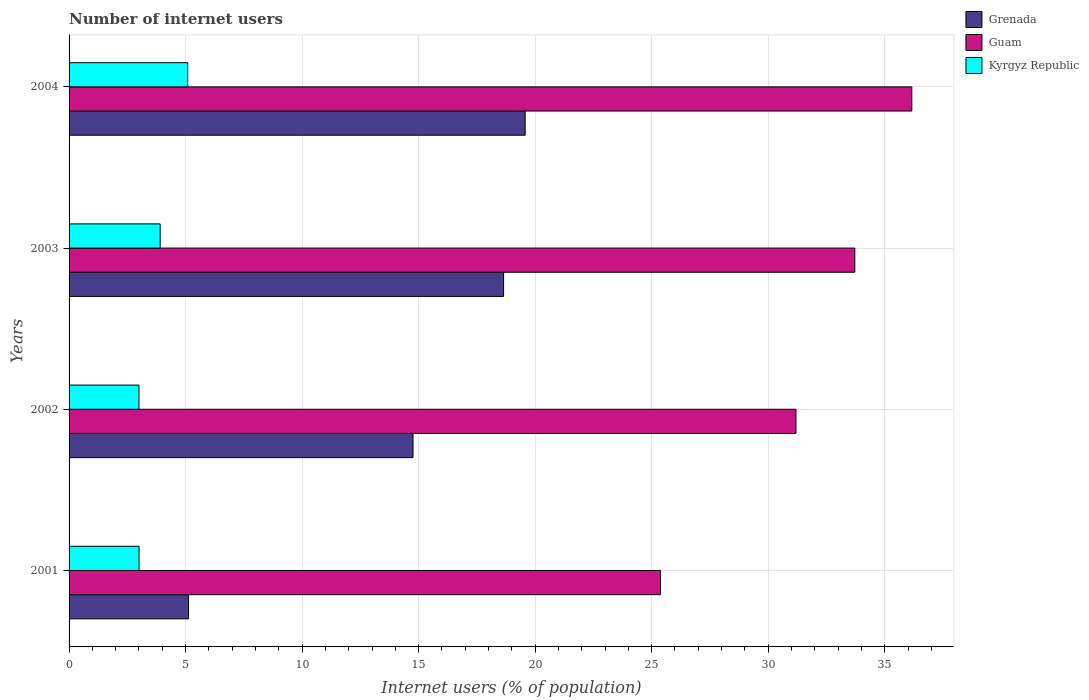How many different coloured bars are there?
Ensure brevity in your answer.  3. What is the number of internet users in Kyrgyz Republic in 2001?
Provide a succinct answer. 3. Across all years, what is the maximum number of internet users in Grenada?
Your response must be concise. 19.57. Across all years, what is the minimum number of internet users in Guam?
Your answer should be very brief. 25.38. In which year was the number of internet users in Kyrgyz Republic maximum?
Provide a succinct answer. 2004. In which year was the number of internet users in Kyrgyz Republic minimum?
Make the answer very short. 2002. What is the total number of internet users in Grenada in the graph?
Your answer should be compact. 58.1. What is the difference between the number of internet users in Grenada in 2002 and that in 2004?
Offer a very short reply. -4.81. What is the difference between the number of internet users in Guam in 2001 and the number of internet users in Grenada in 2003?
Give a very brief answer. 6.74. What is the average number of internet users in Guam per year?
Make the answer very short. 31.61. In the year 2004, what is the difference between the number of internet users in Grenada and number of internet users in Guam?
Offer a terse response. -16.59. What is the ratio of the number of internet users in Kyrgyz Republic in 2001 to that in 2004?
Make the answer very short. 0.59. Is the difference between the number of internet users in Grenada in 2001 and 2002 greater than the difference between the number of internet users in Guam in 2001 and 2002?
Offer a terse response. No. What is the difference between the highest and the second highest number of internet users in Grenada?
Your answer should be very brief. 0.93. What is the difference between the highest and the lowest number of internet users in Guam?
Provide a succinct answer. 10.78. In how many years, is the number of internet users in Grenada greater than the average number of internet users in Grenada taken over all years?
Your answer should be very brief. 3. Is the sum of the number of internet users in Kyrgyz Republic in 2003 and 2004 greater than the maximum number of internet users in Guam across all years?
Give a very brief answer. No. What does the 2nd bar from the top in 2002 represents?
Offer a terse response. Guam. What does the 3rd bar from the bottom in 2003 represents?
Offer a very short reply. Kyrgyz Republic. Is it the case that in every year, the sum of the number of internet users in Kyrgyz Republic and number of internet users in Guam is greater than the number of internet users in Grenada?
Provide a succinct answer. Yes. How many bars are there?
Make the answer very short. 12. Are all the bars in the graph horizontal?
Your answer should be compact. Yes. Are the values on the major ticks of X-axis written in scientific E-notation?
Offer a very short reply. No. Does the graph contain grids?
Ensure brevity in your answer.  Yes. Where does the legend appear in the graph?
Give a very brief answer. Top right. What is the title of the graph?
Provide a succinct answer. Number of internet users. Does "Central Europe" appear as one of the legend labels in the graph?
Give a very brief answer. No. What is the label or title of the X-axis?
Your answer should be very brief. Internet users (% of population). What is the Internet users (% of population) of Grenada in 2001?
Give a very brief answer. 5.13. What is the Internet users (% of population) in Guam in 2001?
Offer a very short reply. 25.38. What is the Internet users (% of population) of Kyrgyz Republic in 2001?
Give a very brief answer. 3. What is the Internet users (% of population) of Grenada in 2002?
Provide a succinct answer. 14.76. What is the Internet users (% of population) of Guam in 2002?
Give a very brief answer. 31.19. What is the Internet users (% of population) of Kyrgyz Republic in 2002?
Provide a short and direct response. 3. What is the Internet users (% of population) of Grenada in 2003?
Make the answer very short. 18.65. What is the Internet users (% of population) in Guam in 2003?
Offer a very short reply. 33.72. What is the Internet users (% of population) of Kyrgyz Republic in 2003?
Offer a terse response. 3.91. What is the Internet users (% of population) of Grenada in 2004?
Provide a short and direct response. 19.57. What is the Internet users (% of population) of Guam in 2004?
Offer a terse response. 36.16. What is the Internet users (% of population) of Kyrgyz Republic in 2004?
Make the answer very short. 5.09. Across all years, what is the maximum Internet users (% of population) in Grenada?
Provide a short and direct response. 19.57. Across all years, what is the maximum Internet users (% of population) in Guam?
Your answer should be compact. 36.16. Across all years, what is the maximum Internet users (% of population) in Kyrgyz Republic?
Your answer should be compact. 5.09. Across all years, what is the minimum Internet users (% of population) of Grenada?
Your answer should be very brief. 5.13. Across all years, what is the minimum Internet users (% of population) of Guam?
Your answer should be compact. 25.38. Across all years, what is the minimum Internet users (% of population) of Kyrgyz Republic?
Your answer should be very brief. 3. What is the total Internet users (% of population) in Grenada in the graph?
Keep it short and to the point. 58.1. What is the total Internet users (% of population) of Guam in the graph?
Offer a terse response. 126.45. What is the total Internet users (% of population) in Kyrgyz Republic in the graph?
Give a very brief answer. 15. What is the difference between the Internet users (% of population) in Grenada in 2001 and that in 2002?
Your answer should be very brief. -9.63. What is the difference between the Internet users (% of population) in Guam in 2001 and that in 2002?
Provide a succinct answer. -5.81. What is the difference between the Internet users (% of population) of Kyrgyz Republic in 2001 and that in 2002?
Give a very brief answer. 0. What is the difference between the Internet users (% of population) of Grenada in 2001 and that in 2003?
Your answer should be compact. -13.52. What is the difference between the Internet users (% of population) in Guam in 2001 and that in 2003?
Keep it short and to the point. -8.34. What is the difference between the Internet users (% of population) in Kyrgyz Republic in 2001 and that in 2003?
Provide a short and direct response. -0.91. What is the difference between the Internet users (% of population) in Grenada in 2001 and that in 2004?
Provide a succinct answer. -14.44. What is the difference between the Internet users (% of population) of Guam in 2001 and that in 2004?
Your answer should be very brief. -10.78. What is the difference between the Internet users (% of population) of Kyrgyz Republic in 2001 and that in 2004?
Your answer should be very brief. -2.09. What is the difference between the Internet users (% of population) in Grenada in 2002 and that in 2003?
Offer a very short reply. -3.89. What is the difference between the Internet users (% of population) in Guam in 2002 and that in 2003?
Your answer should be compact. -2.52. What is the difference between the Internet users (% of population) in Kyrgyz Republic in 2002 and that in 2003?
Your response must be concise. -0.91. What is the difference between the Internet users (% of population) of Grenada in 2002 and that in 2004?
Offer a very short reply. -4.81. What is the difference between the Internet users (% of population) in Guam in 2002 and that in 2004?
Provide a succinct answer. -4.97. What is the difference between the Internet users (% of population) of Kyrgyz Republic in 2002 and that in 2004?
Give a very brief answer. -2.09. What is the difference between the Internet users (% of population) in Grenada in 2003 and that in 2004?
Offer a terse response. -0.93. What is the difference between the Internet users (% of population) in Guam in 2003 and that in 2004?
Your response must be concise. -2.45. What is the difference between the Internet users (% of population) of Kyrgyz Republic in 2003 and that in 2004?
Your response must be concise. -1.18. What is the difference between the Internet users (% of population) of Grenada in 2001 and the Internet users (% of population) of Guam in 2002?
Your response must be concise. -26.06. What is the difference between the Internet users (% of population) of Grenada in 2001 and the Internet users (% of population) of Kyrgyz Republic in 2002?
Your response must be concise. 2.13. What is the difference between the Internet users (% of population) in Guam in 2001 and the Internet users (% of population) in Kyrgyz Republic in 2002?
Keep it short and to the point. 22.38. What is the difference between the Internet users (% of population) of Grenada in 2001 and the Internet users (% of population) of Guam in 2003?
Provide a short and direct response. -28.59. What is the difference between the Internet users (% of population) in Grenada in 2001 and the Internet users (% of population) in Kyrgyz Republic in 2003?
Your response must be concise. 1.22. What is the difference between the Internet users (% of population) of Guam in 2001 and the Internet users (% of population) of Kyrgyz Republic in 2003?
Keep it short and to the point. 21.47. What is the difference between the Internet users (% of population) in Grenada in 2001 and the Internet users (% of population) in Guam in 2004?
Your answer should be compact. -31.03. What is the difference between the Internet users (% of population) of Grenada in 2001 and the Internet users (% of population) of Kyrgyz Republic in 2004?
Your answer should be compact. 0.04. What is the difference between the Internet users (% of population) of Guam in 2001 and the Internet users (% of population) of Kyrgyz Republic in 2004?
Your answer should be very brief. 20.29. What is the difference between the Internet users (% of population) of Grenada in 2002 and the Internet users (% of population) of Guam in 2003?
Offer a very short reply. -18.96. What is the difference between the Internet users (% of population) of Grenada in 2002 and the Internet users (% of population) of Kyrgyz Republic in 2003?
Make the answer very short. 10.85. What is the difference between the Internet users (% of population) in Guam in 2002 and the Internet users (% of population) in Kyrgyz Republic in 2003?
Provide a short and direct response. 27.28. What is the difference between the Internet users (% of population) of Grenada in 2002 and the Internet users (% of population) of Guam in 2004?
Provide a succinct answer. -21.4. What is the difference between the Internet users (% of population) in Grenada in 2002 and the Internet users (% of population) in Kyrgyz Republic in 2004?
Make the answer very short. 9.67. What is the difference between the Internet users (% of population) of Guam in 2002 and the Internet users (% of population) of Kyrgyz Republic in 2004?
Offer a terse response. 26.1. What is the difference between the Internet users (% of population) of Grenada in 2003 and the Internet users (% of population) of Guam in 2004?
Offer a very short reply. -17.52. What is the difference between the Internet users (% of population) in Grenada in 2003 and the Internet users (% of population) in Kyrgyz Republic in 2004?
Provide a short and direct response. 13.55. What is the difference between the Internet users (% of population) of Guam in 2003 and the Internet users (% of population) of Kyrgyz Republic in 2004?
Ensure brevity in your answer.  28.63. What is the average Internet users (% of population) in Grenada per year?
Offer a very short reply. 14.53. What is the average Internet users (% of population) in Guam per year?
Offer a very short reply. 31.61. What is the average Internet users (% of population) of Kyrgyz Republic per year?
Your response must be concise. 3.75. In the year 2001, what is the difference between the Internet users (% of population) in Grenada and Internet users (% of population) in Guam?
Give a very brief answer. -20.25. In the year 2001, what is the difference between the Internet users (% of population) in Grenada and Internet users (% of population) in Kyrgyz Republic?
Your response must be concise. 2.13. In the year 2001, what is the difference between the Internet users (% of population) in Guam and Internet users (% of population) in Kyrgyz Republic?
Offer a terse response. 22.38. In the year 2002, what is the difference between the Internet users (% of population) in Grenada and Internet users (% of population) in Guam?
Make the answer very short. -16.43. In the year 2002, what is the difference between the Internet users (% of population) of Grenada and Internet users (% of population) of Kyrgyz Republic?
Ensure brevity in your answer.  11.76. In the year 2002, what is the difference between the Internet users (% of population) of Guam and Internet users (% of population) of Kyrgyz Republic?
Offer a terse response. 28.19. In the year 2003, what is the difference between the Internet users (% of population) in Grenada and Internet users (% of population) in Guam?
Your answer should be very brief. -15.07. In the year 2003, what is the difference between the Internet users (% of population) of Grenada and Internet users (% of population) of Kyrgyz Republic?
Give a very brief answer. 14.74. In the year 2003, what is the difference between the Internet users (% of population) of Guam and Internet users (% of population) of Kyrgyz Republic?
Provide a short and direct response. 29.81. In the year 2004, what is the difference between the Internet users (% of population) in Grenada and Internet users (% of population) in Guam?
Give a very brief answer. -16.59. In the year 2004, what is the difference between the Internet users (% of population) of Grenada and Internet users (% of population) of Kyrgyz Republic?
Offer a terse response. 14.48. In the year 2004, what is the difference between the Internet users (% of population) in Guam and Internet users (% of population) in Kyrgyz Republic?
Make the answer very short. 31.07. What is the ratio of the Internet users (% of population) of Grenada in 2001 to that in 2002?
Your answer should be compact. 0.35. What is the ratio of the Internet users (% of population) in Guam in 2001 to that in 2002?
Ensure brevity in your answer.  0.81. What is the ratio of the Internet users (% of population) of Grenada in 2001 to that in 2003?
Give a very brief answer. 0.28. What is the ratio of the Internet users (% of population) in Guam in 2001 to that in 2003?
Ensure brevity in your answer.  0.75. What is the ratio of the Internet users (% of population) in Kyrgyz Republic in 2001 to that in 2003?
Provide a short and direct response. 0.77. What is the ratio of the Internet users (% of population) of Grenada in 2001 to that in 2004?
Provide a short and direct response. 0.26. What is the ratio of the Internet users (% of population) in Guam in 2001 to that in 2004?
Offer a very short reply. 0.7. What is the ratio of the Internet users (% of population) in Kyrgyz Republic in 2001 to that in 2004?
Your response must be concise. 0.59. What is the ratio of the Internet users (% of population) in Grenada in 2002 to that in 2003?
Provide a short and direct response. 0.79. What is the ratio of the Internet users (% of population) in Guam in 2002 to that in 2003?
Your response must be concise. 0.93. What is the ratio of the Internet users (% of population) of Kyrgyz Republic in 2002 to that in 2003?
Ensure brevity in your answer.  0.77. What is the ratio of the Internet users (% of population) of Grenada in 2002 to that in 2004?
Offer a very short reply. 0.75. What is the ratio of the Internet users (% of population) of Guam in 2002 to that in 2004?
Your answer should be compact. 0.86. What is the ratio of the Internet users (% of population) of Kyrgyz Republic in 2002 to that in 2004?
Ensure brevity in your answer.  0.59. What is the ratio of the Internet users (% of population) in Grenada in 2003 to that in 2004?
Your answer should be compact. 0.95. What is the ratio of the Internet users (% of population) in Guam in 2003 to that in 2004?
Ensure brevity in your answer.  0.93. What is the ratio of the Internet users (% of population) of Kyrgyz Republic in 2003 to that in 2004?
Give a very brief answer. 0.77. What is the difference between the highest and the second highest Internet users (% of population) of Grenada?
Ensure brevity in your answer.  0.93. What is the difference between the highest and the second highest Internet users (% of population) of Guam?
Your answer should be compact. 2.45. What is the difference between the highest and the second highest Internet users (% of population) of Kyrgyz Republic?
Offer a terse response. 1.18. What is the difference between the highest and the lowest Internet users (% of population) in Grenada?
Your answer should be very brief. 14.44. What is the difference between the highest and the lowest Internet users (% of population) in Guam?
Offer a very short reply. 10.78. What is the difference between the highest and the lowest Internet users (% of population) in Kyrgyz Republic?
Keep it short and to the point. 2.09. 